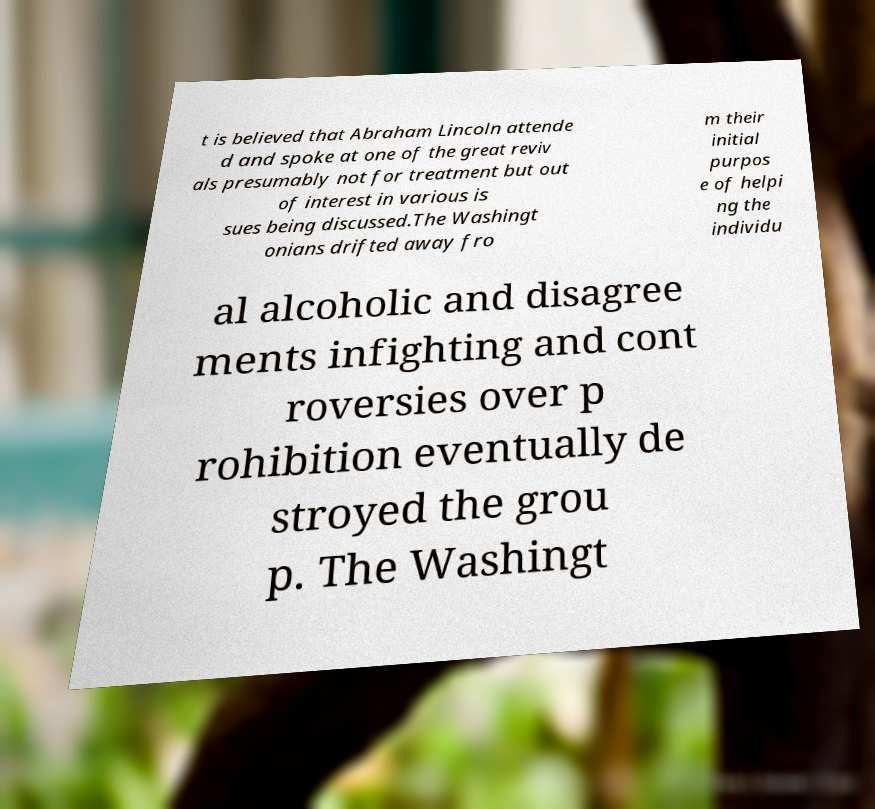For documentation purposes, I need the text within this image transcribed. Could you provide that? t is believed that Abraham Lincoln attende d and spoke at one of the great reviv als presumably not for treatment but out of interest in various is sues being discussed.The Washingt onians drifted away fro m their initial purpos e of helpi ng the individu al alcoholic and disagree ments infighting and cont roversies over p rohibition eventually de stroyed the grou p. The Washingt 